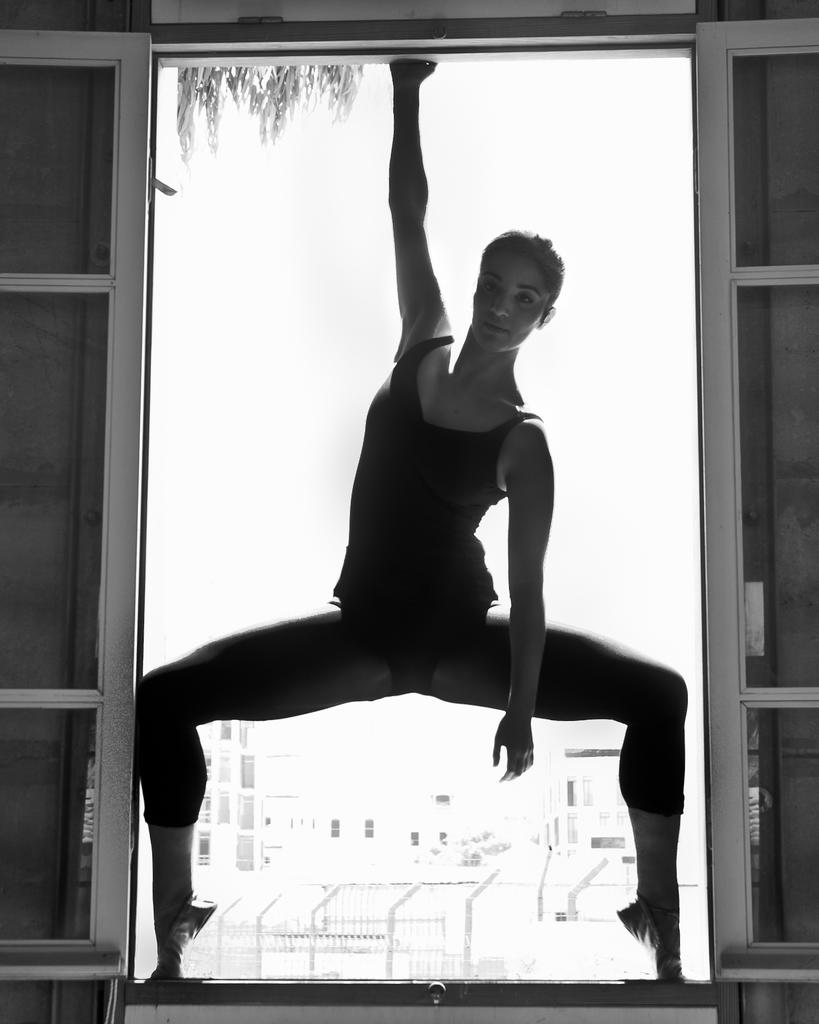What is the color scheme of the image? The image is black and white. Who or what is the main subject in the image? There is a girl in the image. What can be seen in the background of the image? There are buildings in the background of the image. What type of net is being used by the girl in the image? There is no net present in the image; it only features a girl and buildings in the background. Can you tell me which verse is being recited by the girl in the image? There is no indication in the image that the girl is reciting a verse. 